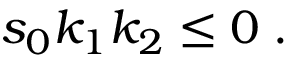Convert formula to latex. <formula><loc_0><loc_0><loc_500><loc_500>s _ { 0 } k _ { 1 } k _ { 2 } \leq 0 \, .</formula> 